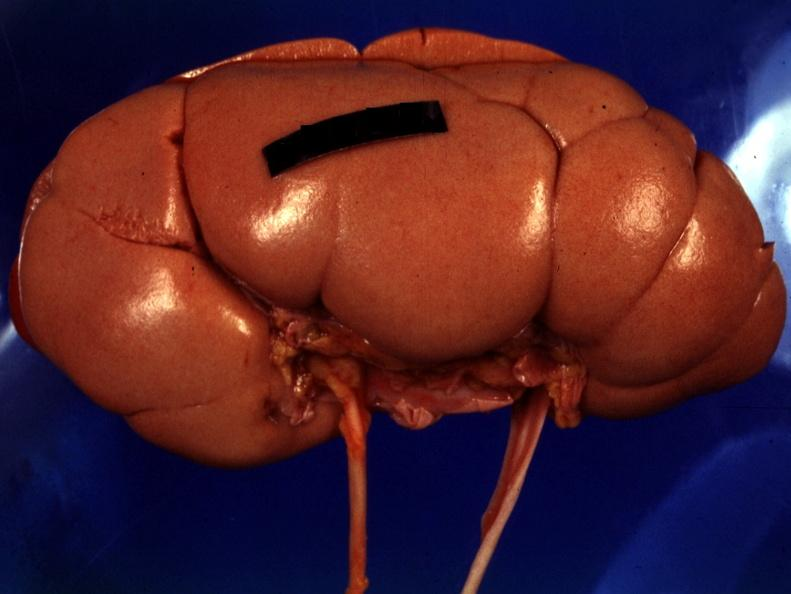where is this?
Answer the question using a single word or phrase. Urinary 